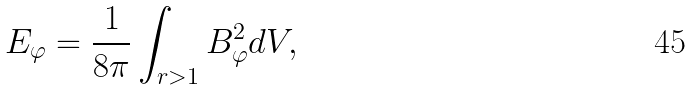Convert formula to latex. <formula><loc_0><loc_0><loc_500><loc_500>E _ { \varphi } = \frac { 1 } { 8 \pi } \int _ { r > 1 } B _ { \varphi } ^ { 2 } d V ,</formula> 